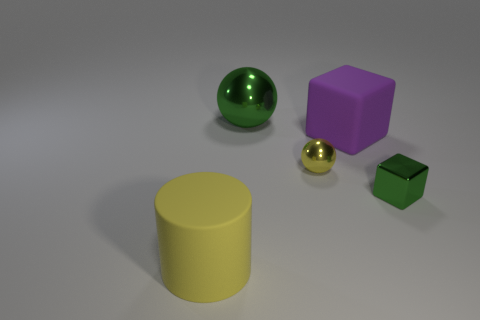Add 4 large metal spheres. How many objects exist? 9 Subtract all cubes. How many objects are left? 3 Add 4 small brown matte objects. How many small brown matte objects exist? 4 Subtract 0 green cylinders. How many objects are left? 5 Subtract all yellow metal things. Subtract all tiny cyan objects. How many objects are left? 4 Add 1 small green cubes. How many small green cubes are left? 2 